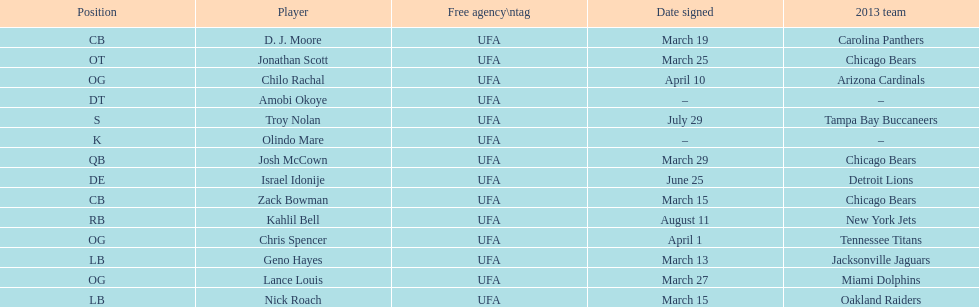How many players play cb or og? 5. 